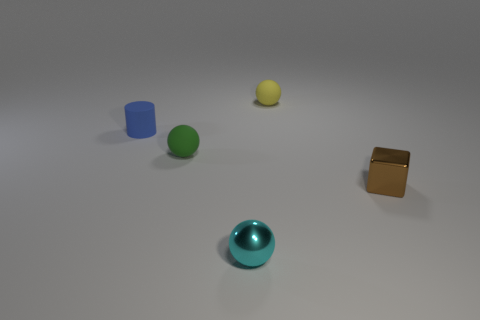Add 2 gray metallic blocks. How many objects exist? 7 Subtract all blocks. How many objects are left? 4 Subtract all tiny green matte balls. Subtract all tiny brown blocks. How many objects are left? 3 Add 5 small metal spheres. How many small metal spheres are left? 6 Add 4 green matte spheres. How many green matte spheres exist? 5 Subtract 0 cyan cylinders. How many objects are left? 5 